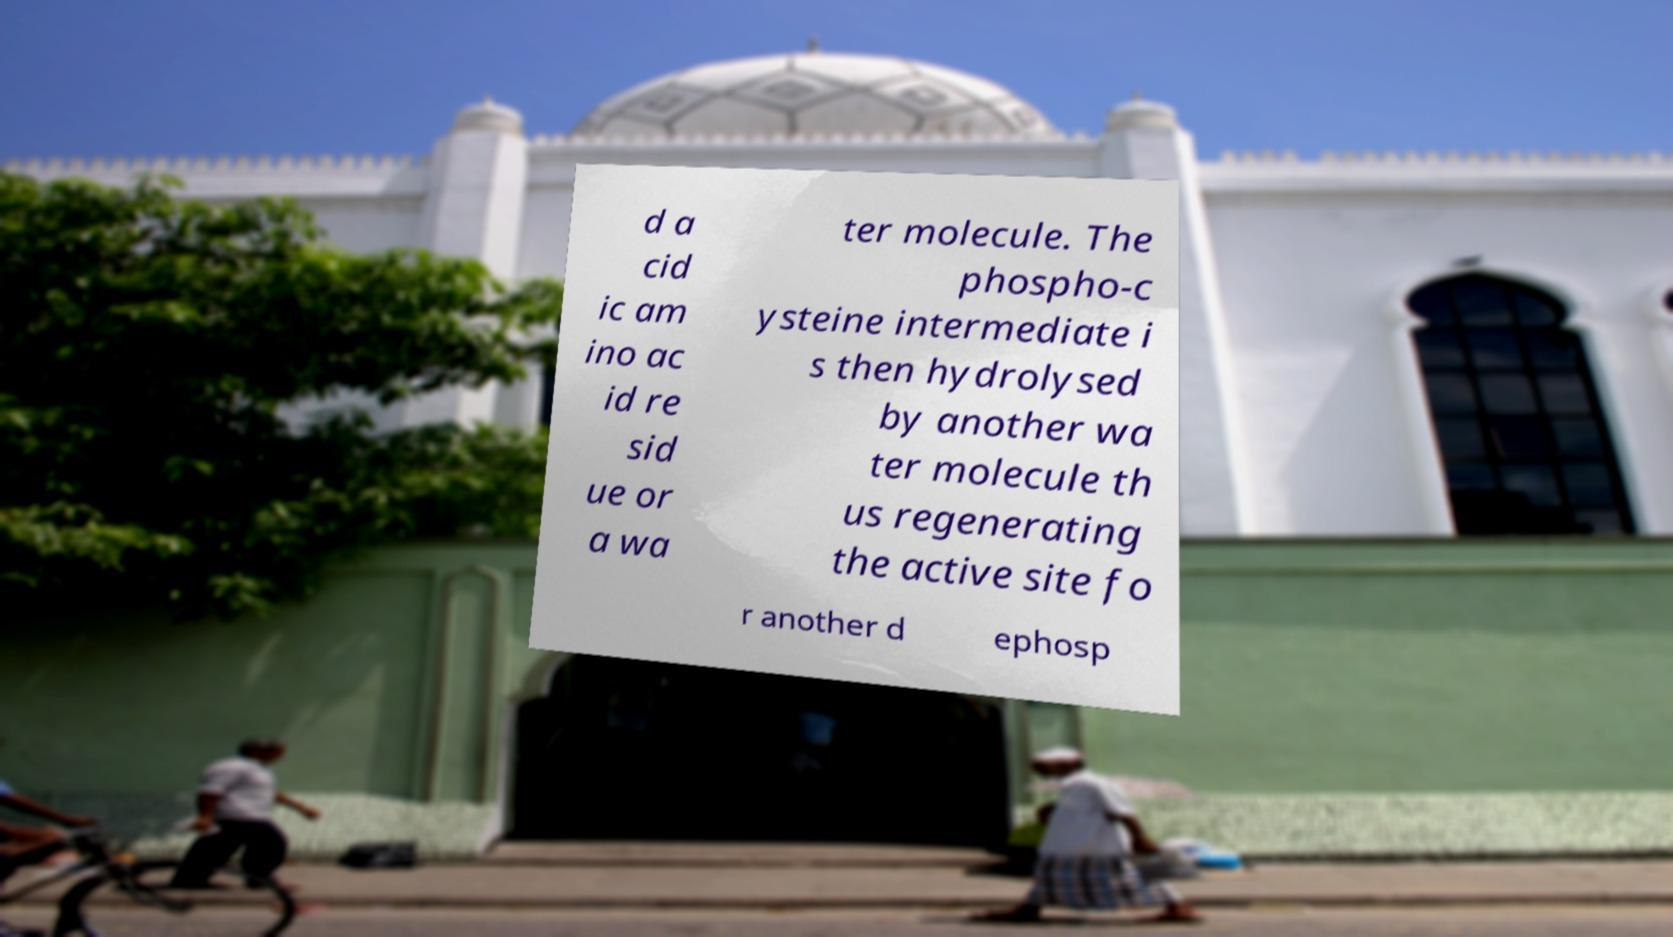Can you accurately transcribe the text from the provided image for me? d a cid ic am ino ac id re sid ue or a wa ter molecule. The phospho-c ysteine intermediate i s then hydrolysed by another wa ter molecule th us regenerating the active site fo r another d ephosp 